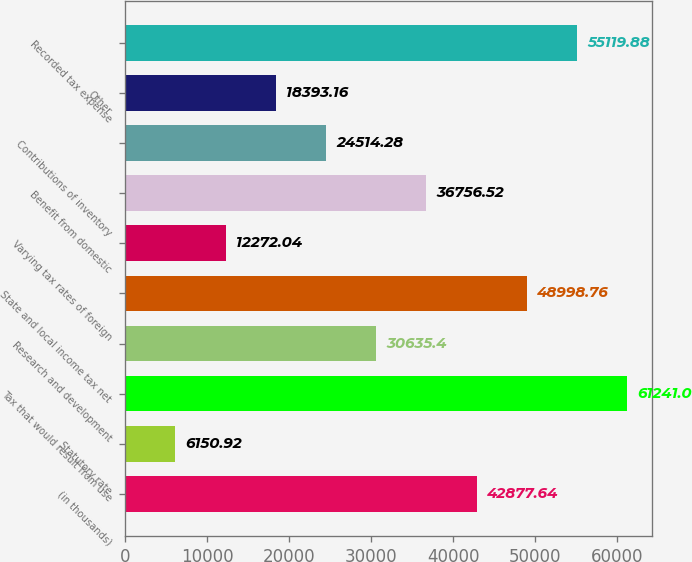<chart> <loc_0><loc_0><loc_500><loc_500><bar_chart><fcel>(in thousands)<fcel>Statutory rate<fcel>Tax that would result from use<fcel>Research and development<fcel>State and local income tax net<fcel>Varying tax rates of foreign<fcel>Benefit from domestic<fcel>Contributions of inventory<fcel>Other<fcel>Recorded tax expense<nl><fcel>42877.6<fcel>6150.92<fcel>61241<fcel>30635.4<fcel>48998.8<fcel>12272<fcel>36756.5<fcel>24514.3<fcel>18393.2<fcel>55119.9<nl></chart> 